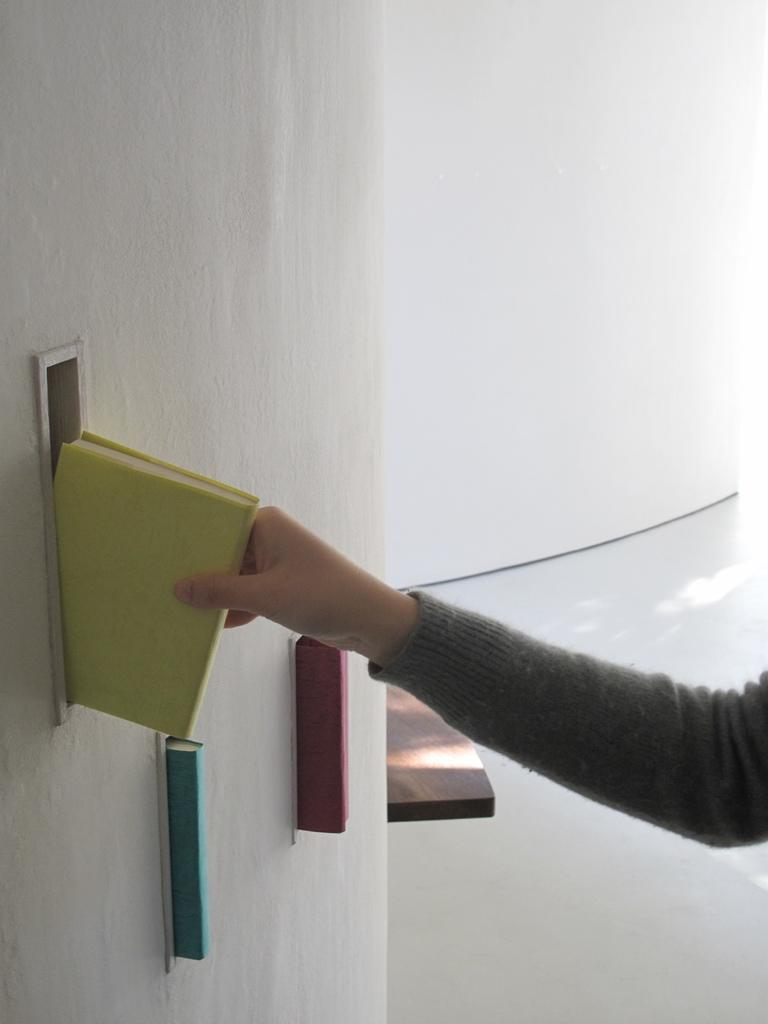What is the main subject in the foreground of the image? There is a person in the foreground of the image. What is the person holding in their hand? The person is holding a book in their hand. What piece of furniture can be seen in the image? There is a table in the image. What type of objects are present in the image? There are books in the image. What can be seen in the background of the image? There is a wall in the background of the image. Can you describe the possible setting of the image? The image may have been taken in a hall. What type of cabbage is being served in the morning in the image? There is no cabbage or morning meal depicted in the image; it features a person holding a book and surrounded by books and a table. 